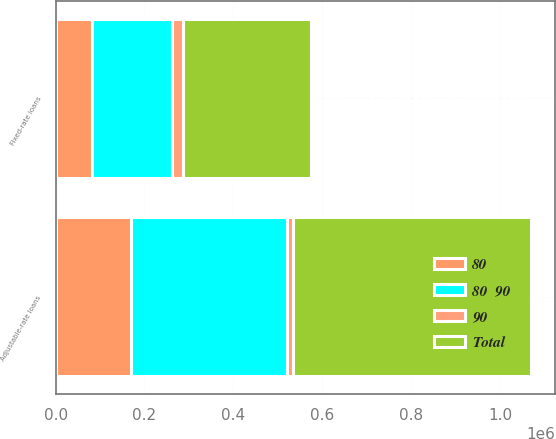Convert chart. <chart><loc_0><loc_0><loc_500><loc_500><stacked_bar_chart><ecel><fcel>Adjustable-rate loans<fcel>Fixed-rate loans<nl><fcel>80  90<fcel>349035<fcel>180159<nl><fcel>80<fcel>170626<fcel>81147<nl><fcel>90<fcel>15282<fcel>25588<nl><fcel>Total<fcel>534943<fcel>286894<nl></chart> 